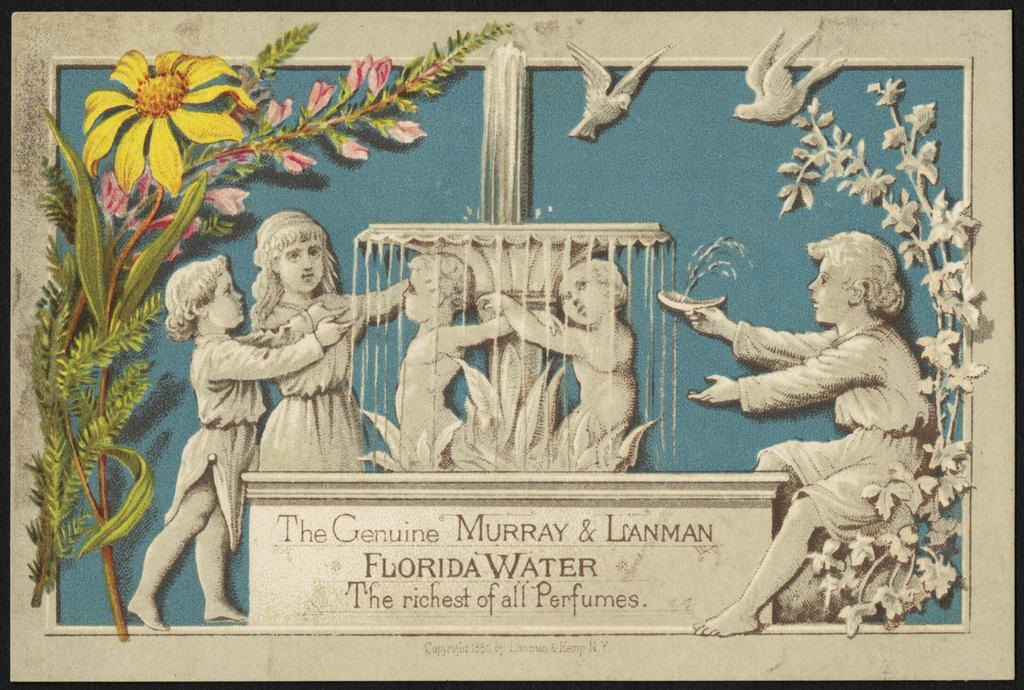What is the main subject of the image? There is a depiction of children in the image. What other elements can be seen in the image? There is a fountain, plants, flowers, and birds in the image. Is there any text present in the image? Yes, there is text written at the bottom of the image. What type of cheese is being observed by the children in the image? There is no cheese present in the image; it features children, a fountain, plants, flowers, birds, and text. Can you tell me how many toads are sitting on the fountain in the image? There are no toads present in the image; it features children, a fountain, plants, flowers, birds, and text. 